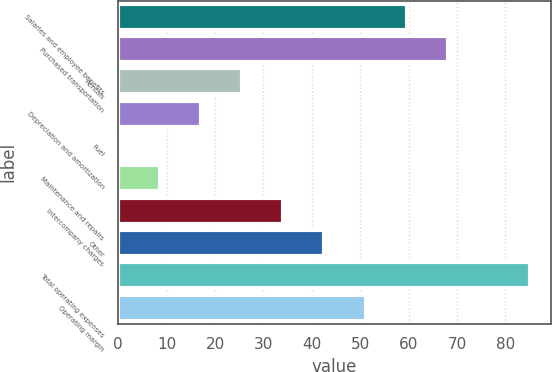<chart> <loc_0><loc_0><loc_500><loc_500><bar_chart><fcel>Salaries and employee benefits<fcel>Purchased transportation<fcel>Rentals<fcel>Depreciation and amortization<fcel>Fuel<fcel>Maintenance and repairs<fcel>Intercompany charges<fcel>Other<fcel>Total operating expenses<fcel>Operating margin<nl><fcel>59.6<fcel>68.1<fcel>25.6<fcel>17.1<fcel>0.1<fcel>8.6<fcel>34.1<fcel>42.6<fcel>85.1<fcel>51.1<nl></chart> 